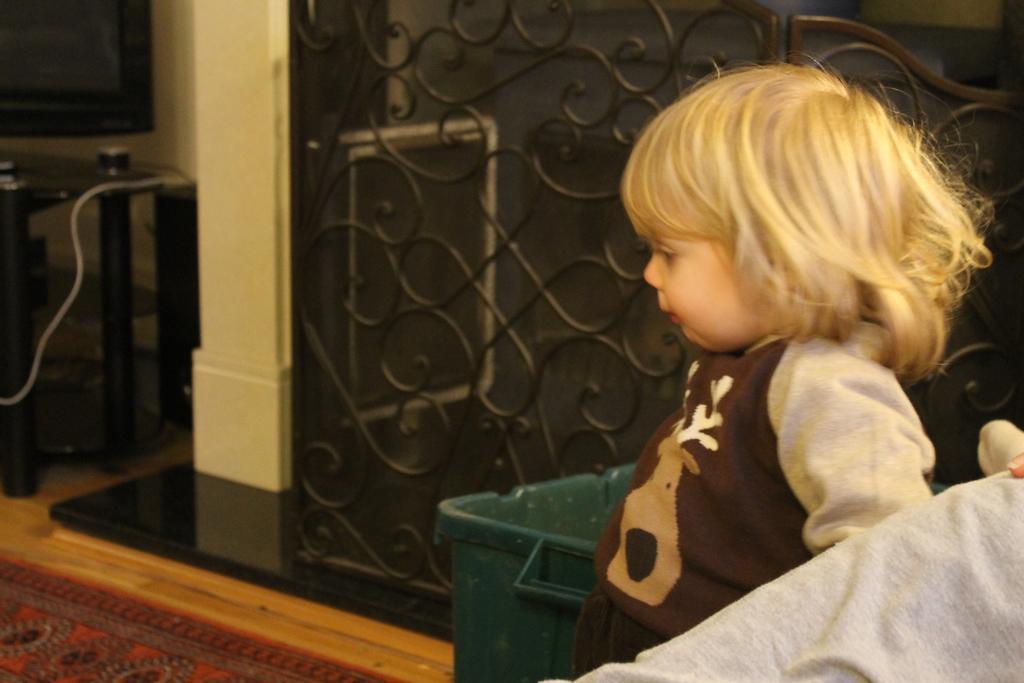In one or two sentences, can you explain what this image depicts? In this image we can see a kid standing on the floor, carpet, grills and a bin. 